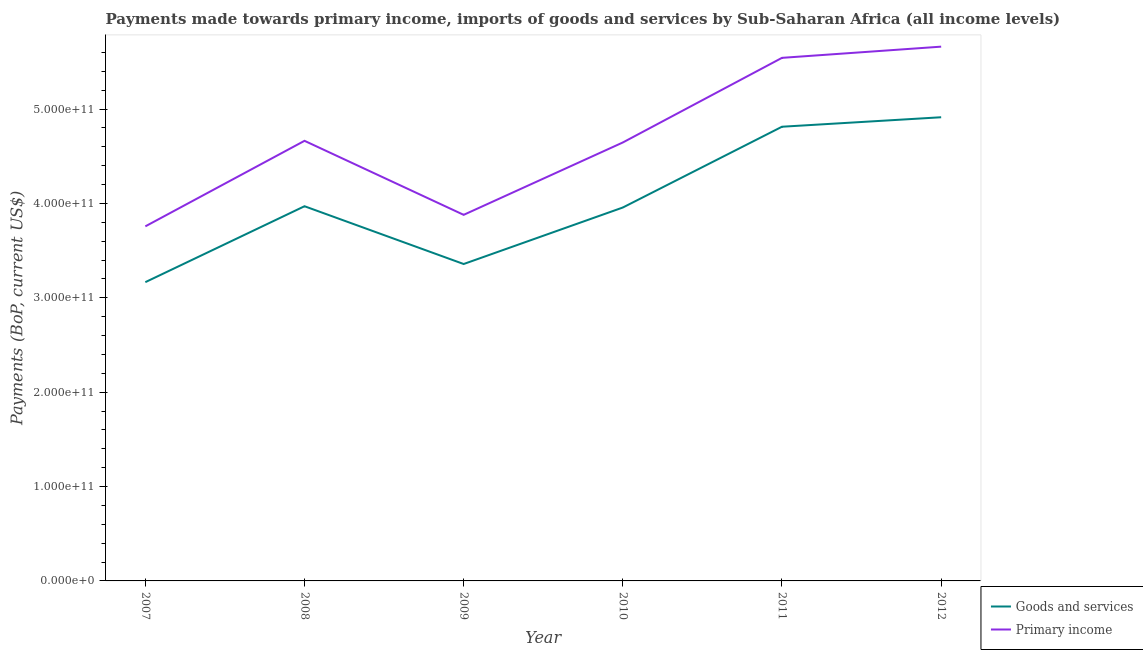What is the payments made towards primary income in 2011?
Give a very brief answer. 5.54e+11. Across all years, what is the maximum payments made towards goods and services?
Keep it short and to the point. 4.91e+11. Across all years, what is the minimum payments made towards goods and services?
Give a very brief answer. 3.17e+11. In which year was the payments made towards goods and services maximum?
Give a very brief answer. 2012. What is the total payments made towards primary income in the graph?
Make the answer very short. 2.81e+12. What is the difference between the payments made towards primary income in 2008 and that in 2011?
Keep it short and to the point. -8.79e+1. What is the difference between the payments made towards primary income in 2011 and the payments made towards goods and services in 2010?
Your answer should be compact. 1.59e+11. What is the average payments made towards primary income per year?
Give a very brief answer. 4.69e+11. In the year 2010, what is the difference between the payments made towards primary income and payments made towards goods and services?
Your response must be concise. 6.89e+1. What is the ratio of the payments made towards goods and services in 2008 to that in 2012?
Your response must be concise. 0.81. Is the difference between the payments made towards primary income in 2008 and 2009 greater than the difference between the payments made towards goods and services in 2008 and 2009?
Offer a very short reply. Yes. What is the difference between the highest and the second highest payments made towards goods and services?
Offer a very short reply. 1.00e+1. What is the difference between the highest and the lowest payments made towards primary income?
Give a very brief answer. 1.90e+11. In how many years, is the payments made towards goods and services greater than the average payments made towards goods and services taken over all years?
Your response must be concise. 2. Is the sum of the payments made towards primary income in 2007 and 2012 greater than the maximum payments made towards goods and services across all years?
Your answer should be compact. Yes. How many lines are there?
Your answer should be very brief. 2. What is the difference between two consecutive major ticks on the Y-axis?
Keep it short and to the point. 1.00e+11. Are the values on the major ticks of Y-axis written in scientific E-notation?
Your answer should be very brief. Yes. Does the graph contain grids?
Offer a very short reply. No. How are the legend labels stacked?
Your answer should be compact. Vertical. What is the title of the graph?
Your answer should be compact. Payments made towards primary income, imports of goods and services by Sub-Saharan Africa (all income levels). What is the label or title of the Y-axis?
Make the answer very short. Payments (BoP, current US$). What is the Payments (BoP, current US$) of Goods and services in 2007?
Offer a terse response. 3.17e+11. What is the Payments (BoP, current US$) of Primary income in 2007?
Provide a short and direct response. 3.76e+11. What is the Payments (BoP, current US$) of Goods and services in 2008?
Ensure brevity in your answer.  3.97e+11. What is the Payments (BoP, current US$) of Primary income in 2008?
Offer a very short reply. 4.66e+11. What is the Payments (BoP, current US$) in Goods and services in 2009?
Your response must be concise. 3.36e+11. What is the Payments (BoP, current US$) of Primary income in 2009?
Your response must be concise. 3.88e+11. What is the Payments (BoP, current US$) in Goods and services in 2010?
Make the answer very short. 3.96e+11. What is the Payments (BoP, current US$) in Primary income in 2010?
Keep it short and to the point. 4.65e+11. What is the Payments (BoP, current US$) in Goods and services in 2011?
Keep it short and to the point. 4.81e+11. What is the Payments (BoP, current US$) in Primary income in 2011?
Give a very brief answer. 5.54e+11. What is the Payments (BoP, current US$) of Goods and services in 2012?
Offer a terse response. 4.91e+11. What is the Payments (BoP, current US$) of Primary income in 2012?
Offer a very short reply. 5.66e+11. Across all years, what is the maximum Payments (BoP, current US$) of Goods and services?
Give a very brief answer. 4.91e+11. Across all years, what is the maximum Payments (BoP, current US$) of Primary income?
Ensure brevity in your answer.  5.66e+11. Across all years, what is the minimum Payments (BoP, current US$) in Goods and services?
Your response must be concise. 3.17e+11. Across all years, what is the minimum Payments (BoP, current US$) in Primary income?
Provide a short and direct response. 3.76e+11. What is the total Payments (BoP, current US$) in Goods and services in the graph?
Your response must be concise. 2.42e+12. What is the total Payments (BoP, current US$) of Primary income in the graph?
Ensure brevity in your answer.  2.81e+12. What is the difference between the Payments (BoP, current US$) in Goods and services in 2007 and that in 2008?
Ensure brevity in your answer.  -8.04e+1. What is the difference between the Payments (BoP, current US$) of Primary income in 2007 and that in 2008?
Your answer should be very brief. -9.06e+1. What is the difference between the Payments (BoP, current US$) of Goods and services in 2007 and that in 2009?
Your answer should be very brief. -1.92e+1. What is the difference between the Payments (BoP, current US$) in Primary income in 2007 and that in 2009?
Your answer should be compact. -1.22e+1. What is the difference between the Payments (BoP, current US$) of Goods and services in 2007 and that in 2010?
Provide a short and direct response. -7.91e+1. What is the difference between the Payments (BoP, current US$) in Primary income in 2007 and that in 2010?
Provide a short and direct response. -8.89e+1. What is the difference between the Payments (BoP, current US$) in Goods and services in 2007 and that in 2011?
Keep it short and to the point. -1.65e+11. What is the difference between the Payments (BoP, current US$) of Primary income in 2007 and that in 2011?
Provide a short and direct response. -1.79e+11. What is the difference between the Payments (BoP, current US$) in Goods and services in 2007 and that in 2012?
Your answer should be compact. -1.75e+11. What is the difference between the Payments (BoP, current US$) in Primary income in 2007 and that in 2012?
Provide a succinct answer. -1.90e+11. What is the difference between the Payments (BoP, current US$) in Goods and services in 2008 and that in 2009?
Provide a short and direct response. 6.12e+1. What is the difference between the Payments (BoP, current US$) in Primary income in 2008 and that in 2009?
Ensure brevity in your answer.  7.84e+1. What is the difference between the Payments (BoP, current US$) in Goods and services in 2008 and that in 2010?
Your answer should be compact. 1.35e+09. What is the difference between the Payments (BoP, current US$) of Primary income in 2008 and that in 2010?
Your answer should be very brief. 1.75e+09. What is the difference between the Payments (BoP, current US$) in Goods and services in 2008 and that in 2011?
Provide a succinct answer. -8.42e+1. What is the difference between the Payments (BoP, current US$) of Primary income in 2008 and that in 2011?
Your answer should be very brief. -8.79e+1. What is the difference between the Payments (BoP, current US$) in Goods and services in 2008 and that in 2012?
Keep it short and to the point. -9.43e+1. What is the difference between the Payments (BoP, current US$) of Primary income in 2008 and that in 2012?
Your answer should be very brief. -9.98e+1. What is the difference between the Payments (BoP, current US$) of Goods and services in 2009 and that in 2010?
Make the answer very short. -5.99e+1. What is the difference between the Payments (BoP, current US$) of Primary income in 2009 and that in 2010?
Your response must be concise. -7.67e+1. What is the difference between the Payments (BoP, current US$) in Goods and services in 2009 and that in 2011?
Give a very brief answer. -1.45e+11. What is the difference between the Payments (BoP, current US$) in Primary income in 2009 and that in 2011?
Your response must be concise. -1.66e+11. What is the difference between the Payments (BoP, current US$) of Goods and services in 2009 and that in 2012?
Keep it short and to the point. -1.56e+11. What is the difference between the Payments (BoP, current US$) in Primary income in 2009 and that in 2012?
Your answer should be compact. -1.78e+11. What is the difference between the Payments (BoP, current US$) in Goods and services in 2010 and that in 2011?
Ensure brevity in your answer.  -8.56e+1. What is the difference between the Payments (BoP, current US$) of Primary income in 2010 and that in 2011?
Ensure brevity in your answer.  -8.97e+1. What is the difference between the Payments (BoP, current US$) of Goods and services in 2010 and that in 2012?
Provide a succinct answer. -9.56e+1. What is the difference between the Payments (BoP, current US$) of Primary income in 2010 and that in 2012?
Ensure brevity in your answer.  -1.02e+11. What is the difference between the Payments (BoP, current US$) of Goods and services in 2011 and that in 2012?
Your response must be concise. -1.00e+1. What is the difference between the Payments (BoP, current US$) in Primary income in 2011 and that in 2012?
Your response must be concise. -1.19e+1. What is the difference between the Payments (BoP, current US$) in Goods and services in 2007 and the Payments (BoP, current US$) in Primary income in 2008?
Keep it short and to the point. -1.50e+11. What is the difference between the Payments (BoP, current US$) in Goods and services in 2007 and the Payments (BoP, current US$) in Primary income in 2009?
Give a very brief answer. -7.13e+1. What is the difference between the Payments (BoP, current US$) of Goods and services in 2007 and the Payments (BoP, current US$) of Primary income in 2010?
Keep it short and to the point. -1.48e+11. What is the difference between the Payments (BoP, current US$) of Goods and services in 2007 and the Payments (BoP, current US$) of Primary income in 2011?
Your answer should be compact. -2.38e+11. What is the difference between the Payments (BoP, current US$) in Goods and services in 2007 and the Payments (BoP, current US$) in Primary income in 2012?
Your answer should be very brief. -2.50e+11. What is the difference between the Payments (BoP, current US$) of Goods and services in 2008 and the Payments (BoP, current US$) of Primary income in 2009?
Your answer should be very brief. 9.13e+09. What is the difference between the Payments (BoP, current US$) of Goods and services in 2008 and the Payments (BoP, current US$) of Primary income in 2010?
Keep it short and to the point. -6.76e+1. What is the difference between the Payments (BoP, current US$) in Goods and services in 2008 and the Payments (BoP, current US$) in Primary income in 2011?
Your answer should be compact. -1.57e+11. What is the difference between the Payments (BoP, current US$) of Goods and services in 2008 and the Payments (BoP, current US$) of Primary income in 2012?
Offer a very short reply. -1.69e+11. What is the difference between the Payments (BoP, current US$) in Goods and services in 2009 and the Payments (BoP, current US$) in Primary income in 2010?
Make the answer very short. -1.29e+11. What is the difference between the Payments (BoP, current US$) of Goods and services in 2009 and the Payments (BoP, current US$) of Primary income in 2011?
Offer a very short reply. -2.18e+11. What is the difference between the Payments (BoP, current US$) of Goods and services in 2009 and the Payments (BoP, current US$) of Primary income in 2012?
Keep it short and to the point. -2.30e+11. What is the difference between the Payments (BoP, current US$) of Goods and services in 2010 and the Payments (BoP, current US$) of Primary income in 2011?
Your response must be concise. -1.59e+11. What is the difference between the Payments (BoP, current US$) of Goods and services in 2010 and the Payments (BoP, current US$) of Primary income in 2012?
Make the answer very short. -1.70e+11. What is the difference between the Payments (BoP, current US$) of Goods and services in 2011 and the Payments (BoP, current US$) of Primary income in 2012?
Provide a succinct answer. -8.48e+1. What is the average Payments (BoP, current US$) in Goods and services per year?
Make the answer very short. 4.03e+11. What is the average Payments (BoP, current US$) of Primary income per year?
Your response must be concise. 4.69e+11. In the year 2007, what is the difference between the Payments (BoP, current US$) of Goods and services and Payments (BoP, current US$) of Primary income?
Your answer should be compact. -5.91e+1. In the year 2008, what is the difference between the Payments (BoP, current US$) of Goods and services and Payments (BoP, current US$) of Primary income?
Offer a very short reply. -6.93e+1. In the year 2009, what is the difference between the Payments (BoP, current US$) in Goods and services and Payments (BoP, current US$) in Primary income?
Give a very brief answer. -5.21e+1. In the year 2010, what is the difference between the Payments (BoP, current US$) of Goods and services and Payments (BoP, current US$) of Primary income?
Make the answer very short. -6.89e+1. In the year 2011, what is the difference between the Payments (BoP, current US$) in Goods and services and Payments (BoP, current US$) in Primary income?
Offer a very short reply. -7.30e+1. In the year 2012, what is the difference between the Payments (BoP, current US$) in Goods and services and Payments (BoP, current US$) in Primary income?
Offer a very short reply. -7.48e+1. What is the ratio of the Payments (BoP, current US$) in Goods and services in 2007 to that in 2008?
Provide a succinct answer. 0.8. What is the ratio of the Payments (BoP, current US$) of Primary income in 2007 to that in 2008?
Your answer should be very brief. 0.81. What is the ratio of the Payments (BoP, current US$) in Goods and services in 2007 to that in 2009?
Ensure brevity in your answer.  0.94. What is the ratio of the Payments (BoP, current US$) of Primary income in 2007 to that in 2009?
Your answer should be compact. 0.97. What is the ratio of the Payments (BoP, current US$) of Goods and services in 2007 to that in 2010?
Keep it short and to the point. 0.8. What is the ratio of the Payments (BoP, current US$) in Primary income in 2007 to that in 2010?
Give a very brief answer. 0.81. What is the ratio of the Payments (BoP, current US$) of Goods and services in 2007 to that in 2011?
Provide a succinct answer. 0.66. What is the ratio of the Payments (BoP, current US$) of Primary income in 2007 to that in 2011?
Make the answer very short. 0.68. What is the ratio of the Payments (BoP, current US$) of Goods and services in 2007 to that in 2012?
Make the answer very short. 0.64. What is the ratio of the Payments (BoP, current US$) of Primary income in 2007 to that in 2012?
Your answer should be compact. 0.66. What is the ratio of the Payments (BoP, current US$) in Goods and services in 2008 to that in 2009?
Provide a succinct answer. 1.18. What is the ratio of the Payments (BoP, current US$) of Primary income in 2008 to that in 2009?
Ensure brevity in your answer.  1.2. What is the ratio of the Payments (BoP, current US$) in Goods and services in 2008 to that in 2011?
Offer a terse response. 0.82. What is the ratio of the Payments (BoP, current US$) in Primary income in 2008 to that in 2011?
Provide a short and direct response. 0.84. What is the ratio of the Payments (BoP, current US$) in Goods and services in 2008 to that in 2012?
Ensure brevity in your answer.  0.81. What is the ratio of the Payments (BoP, current US$) of Primary income in 2008 to that in 2012?
Keep it short and to the point. 0.82. What is the ratio of the Payments (BoP, current US$) of Goods and services in 2009 to that in 2010?
Provide a succinct answer. 0.85. What is the ratio of the Payments (BoP, current US$) of Primary income in 2009 to that in 2010?
Offer a terse response. 0.83. What is the ratio of the Payments (BoP, current US$) of Goods and services in 2009 to that in 2011?
Ensure brevity in your answer.  0.7. What is the ratio of the Payments (BoP, current US$) of Primary income in 2009 to that in 2011?
Offer a very short reply. 0.7. What is the ratio of the Payments (BoP, current US$) of Goods and services in 2009 to that in 2012?
Your answer should be compact. 0.68. What is the ratio of the Payments (BoP, current US$) of Primary income in 2009 to that in 2012?
Make the answer very short. 0.69. What is the ratio of the Payments (BoP, current US$) of Goods and services in 2010 to that in 2011?
Your answer should be compact. 0.82. What is the ratio of the Payments (BoP, current US$) in Primary income in 2010 to that in 2011?
Offer a terse response. 0.84. What is the ratio of the Payments (BoP, current US$) of Goods and services in 2010 to that in 2012?
Your response must be concise. 0.81. What is the ratio of the Payments (BoP, current US$) in Primary income in 2010 to that in 2012?
Your answer should be compact. 0.82. What is the ratio of the Payments (BoP, current US$) in Goods and services in 2011 to that in 2012?
Provide a succinct answer. 0.98. What is the ratio of the Payments (BoP, current US$) in Primary income in 2011 to that in 2012?
Give a very brief answer. 0.98. What is the difference between the highest and the second highest Payments (BoP, current US$) in Goods and services?
Your answer should be compact. 1.00e+1. What is the difference between the highest and the second highest Payments (BoP, current US$) in Primary income?
Provide a short and direct response. 1.19e+1. What is the difference between the highest and the lowest Payments (BoP, current US$) of Goods and services?
Keep it short and to the point. 1.75e+11. What is the difference between the highest and the lowest Payments (BoP, current US$) in Primary income?
Give a very brief answer. 1.90e+11. 